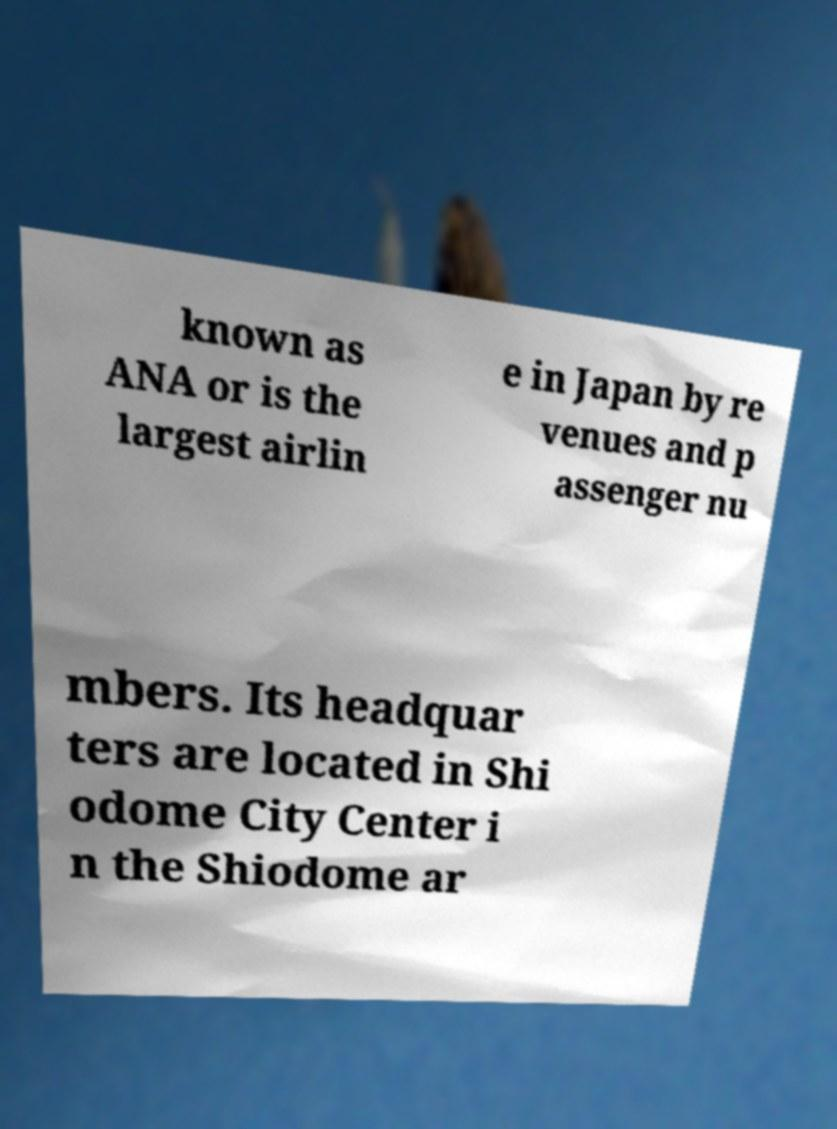Please read and relay the text visible in this image. What does it say? known as ANA or is the largest airlin e in Japan by re venues and p assenger nu mbers. Its headquar ters are located in Shi odome City Center i n the Shiodome ar 